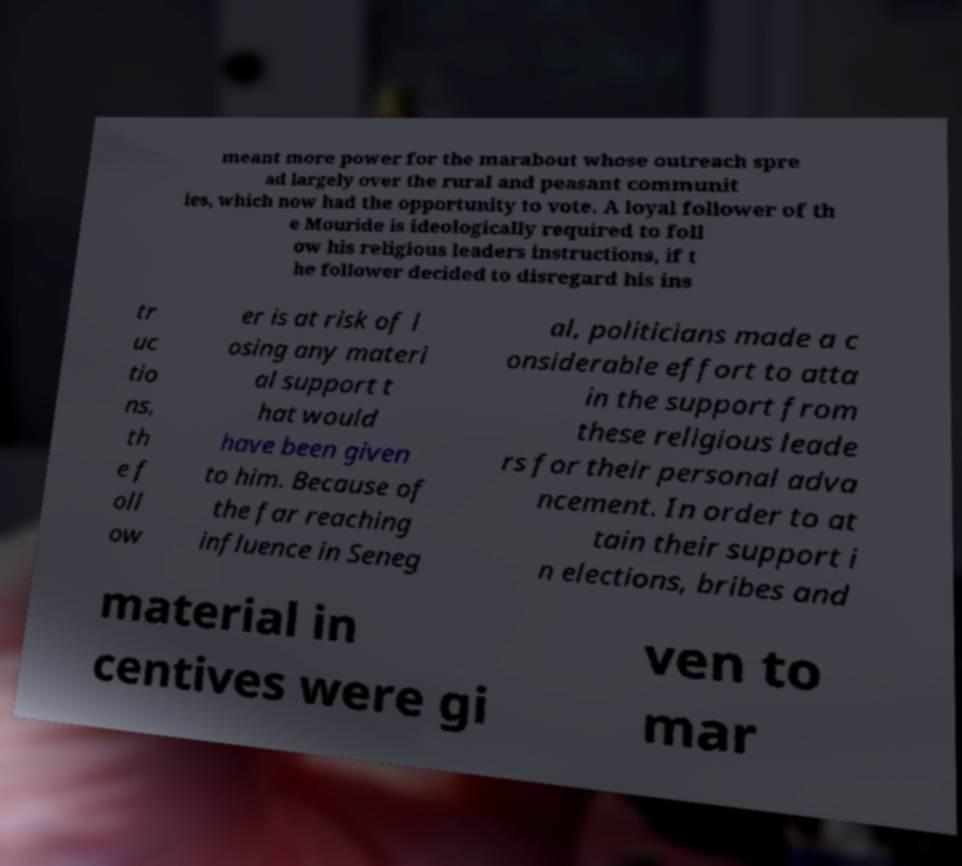Could you assist in decoding the text presented in this image and type it out clearly? meant more power for the marabout whose outreach spre ad largely over the rural and peasant communit ies, which now had the opportunity to vote. A loyal follower of th e Mouride is ideologically required to foll ow his religious leaders instructions, if t he follower decided to disregard his ins tr uc tio ns, th e f oll ow er is at risk of l osing any materi al support t hat would have been given to him. Because of the far reaching influence in Seneg al, politicians made a c onsiderable effort to atta in the support from these religious leade rs for their personal adva ncement. In order to at tain their support i n elections, bribes and material in centives were gi ven to mar 